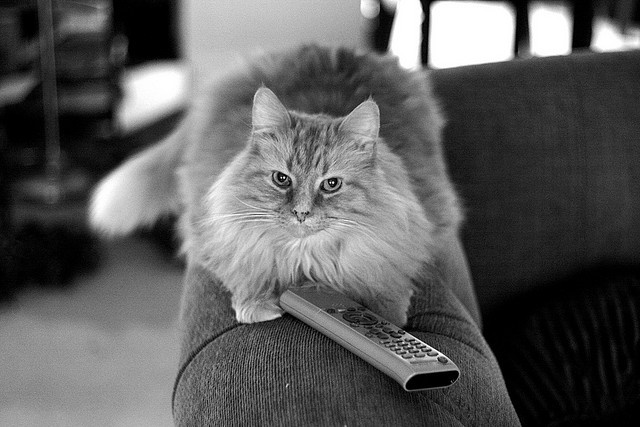Describe the objects in this image and their specific colors. I can see couch in black, gray, and lightgray tones, cat in black, darkgray, gray, and lightgray tones, and remote in black, gray, and lightgray tones in this image. 